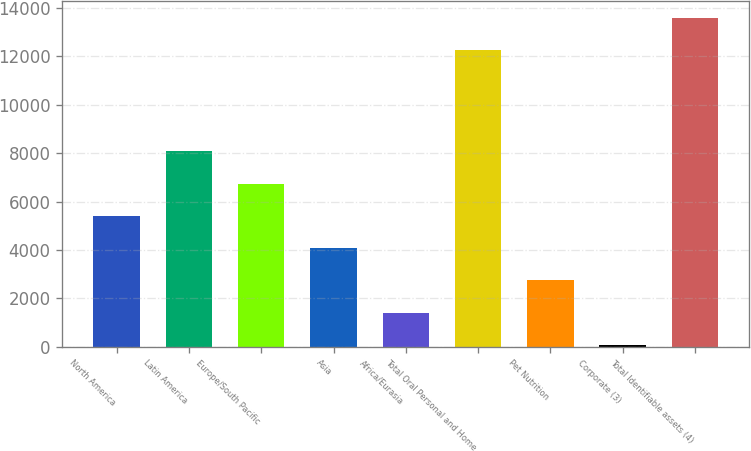Convert chart. <chart><loc_0><loc_0><loc_500><loc_500><bar_chart><fcel>North America<fcel>Latin America<fcel>Europe/South Pacific<fcel>Asia<fcel>Africa/Eurasia<fcel>Total Oral Personal and Home<fcel>Pet Nutrition<fcel>Corporate (3)<fcel>Total Identifiable assets (4)<nl><fcel>5409.2<fcel>8070.8<fcel>6740<fcel>4078.4<fcel>1416.8<fcel>12263<fcel>2747.6<fcel>86<fcel>13593.8<nl></chart> 